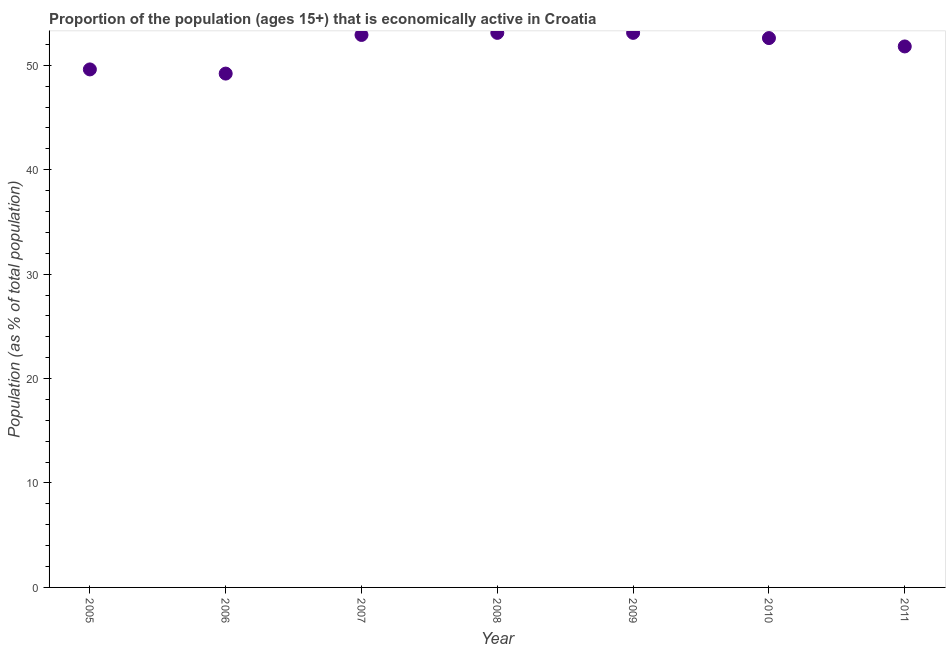What is the percentage of economically active population in 2007?
Provide a short and direct response. 52.9. Across all years, what is the maximum percentage of economically active population?
Make the answer very short. 53.1. Across all years, what is the minimum percentage of economically active population?
Provide a succinct answer. 49.2. What is the sum of the percentage of economically active population?
Ensure brevity in your answer.  362.3. What is the difference between the percentage of economically active population in 2007 and 2009?
Give a very brief answer. -0.2. What is the average percentage of economically active population per year?
Your answer should be compact. 51.76. What is the median percentage of economically active population?
Make the answer very short. 52.6. In how many years, is the percentage of economically active population greater than 6 %?
Offer a terse response. 7. Do a majority of the years between 2007 and 2005 (inclusive) have percentage of economically active population greater than 14 %?
Give a very brief answer. No. What is the ratio of the percentage of economically active population in 2005 to that in 2006?
Your response must be concise. 1.01. Is the percentage of economically active population in 2007 less than that in 2008?
Keep it short and to the point. Yes. Is the difference between the percentage of economically active population in 2006 and 2010 greater than the difference between any two years?
Your answer should be compact. No. What is the difference between the highest and the lowest percentage of economically active population?
Give a very brief answer. 3.9. In how many years, is the percentage of economically active population greater than the average percentage of economically active population taken over all years?
Your response must be concise. 5. Does the percentage of economically active population monotonically increase over the years?
Give a very brief answer. No. What is the difference between two consecutive major ticks on the Y-axis?
Provide a short and direct response. 10. Are the values on the major ticks of Y-axis written in scientific E-notation?
Provide a succinct answer. No. Does the graph contain grids?
Provide a short and direct response. No. What is the title of the graph?
Your answer should be very brief. Proportion of the population (ages 15+) that is economically active in Croatia. What is the label or title of the Y-axis?
Your response must be concise. Population (as % of total population). What is the Population (as % of total population) in 2005?
Your answer should be very brief. 49.6. What is the Population (as % of total population) in 2006?
Ensure brevity in your answer.  49.2. What is the Population (as % of total population) in 2007?
Keep it short and to the point. 52.9. What is the Population (as % of total population) in 2008?
Your answer should be compact. 53.1. What is the Population (as % of total population) in 2009?
Provide a succinct answer. 53.1. What is the Population (as % of total population) in 2010?
Your answer should be compact. 52.6. What is the Population (as % of total population) in 2011?
Your answer should be compact. 51.8. What is the difference between the Population (as % of total population) in 2005 and 2007?
Provide a short and direct response. -3.3. What is the difference between the Population (as % of total population) in 2005 and 2008?
Keep it short and to the point. -3.5. What is the difference between the Population (as % of total population) in 2005 and 2010?
Provide a short and direct response. -3. What is the difference between the Population (as % of total population) in 2006 and 2007?
Offer a very short reply. -3.7. What is the difference between the Population (as % of total population) in 2006 and 2009?
Offer a terse response. -3.9. What is the difference between the Population (as % of total population) in 2006 and 2010?
Your response must be concise. -3.4. What is the difference between the Population (as % of total population) in 2007 and 2010?
Your answer should be very brief. 0.3. What is the difference between the Population (as % of total population) in 2008 and 2009?
Your answer should be very brief. 0. What is the difference between the Population (as % of total population) in 2010 and 2011?
Give a very brief answer. 0.8. What is the ratio of the Population (as % of total population) in 2005 to that in 2007?
Offer a very short reply. 0.94. What is the ratio of the Population (as % of total population) in 2005 to that in 2008?
Ensure brevity in your answer.  0.93. What is the ratio of the Population (as % of total population) in 2005 to that in 2009?
Provide a succinct answer. 0.93. What is the ratio of the Population (as % of total population) in 2005 to that in 2010?
Your answer should be compact. 0.94. What is the ratio of the Population (as % of total population) in 2005 to that in 2011?
Your answer should be very brief. 0.96. What is the ratio of the Population (as % of total population) in 2006 to that in 2008?
Your answer should be very brief. 0.93. What is the ratio of the Population (as % of total population) in 2006 to that in 2009?
Your answer should be compact. 0.93. What is the ratio of the Population (as % of total population) in 2006 to that in 2010?
Your answer should be very brief. 0.94. What is the ratio of the Population (as % of total population) in 2006 to that in 2011?
Provide a short and direct response. 0.95. What is the ratio of the Population (as % of total population) in 2007 to that in 2008?
Offer a very short reply. 1. What is the ratio of the Population (as % of total population) in 2008 to that in 2009?
Give a very brief answer. 1. What is the ratio of the Population (as % of total population) in 2008 to that in 2010?
Provide a succinct answer. 1.01. What is the ratio of the Population (as % of total population) in 2009 to that in 2011?
Your answer should be very brief. 1.02. 